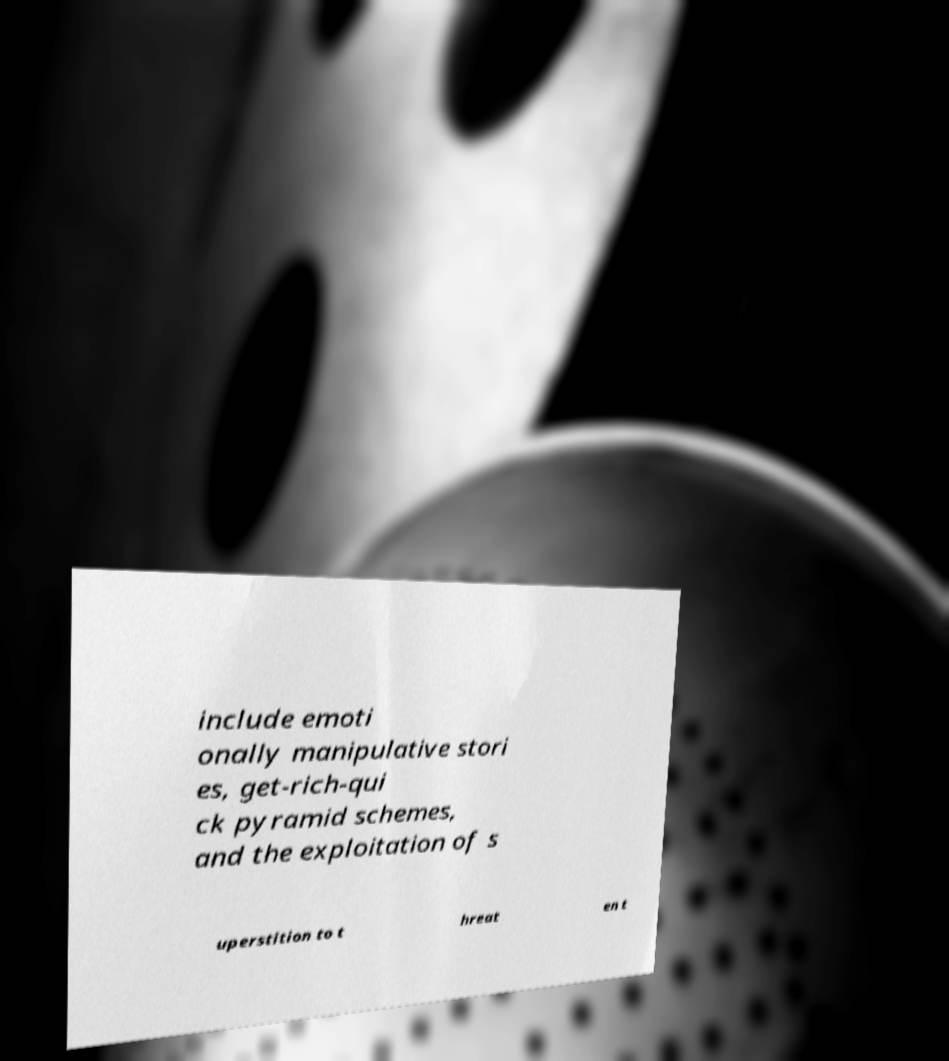There's text embedded in this image that I need extracted. Can you transcribe it verbatim? include emoti onally manipulative stori es, get-rich-qui ck pyramid schemes, and the exploitation of s uperstition to t hreat en t 